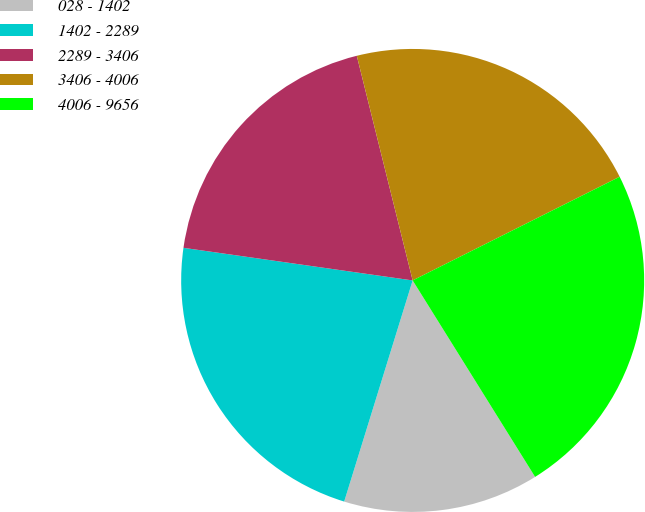<chart> <loc_0><loc_0><loc_500><loc_500><pie_chart><fcel>028 - 1402<fcel>1402 - 2289<fcel>2289 - 3406<fcel>3406 - 4006<fcel>4006 - 9656<nl><fcel>13.65%<fcel>22.47%<fcel>18.87%<fcel>21.49%<fcel>23.52%<nl></chart> 